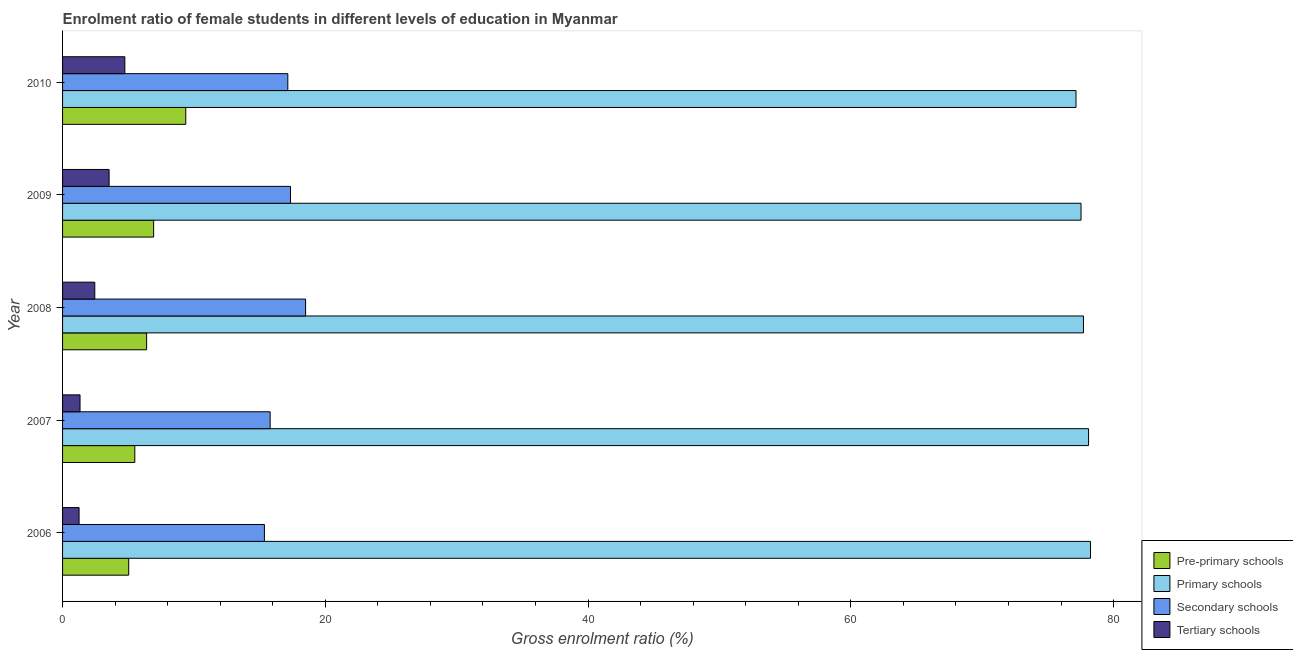How many groups of bars are there?
Your response must be concise. 5. How many bars are there on the 1st tick from the bottom?
Offer a terse response. 4. What is the label of the 5th group of bars from the top?
Make the answer very short. 2006. What is the gross enrolment ratio(male) in tertiary schools in 2006?
Offer a terse response. 1.26. Across all years, what is the maximum gross enrolment ratio(male) in primary schools?
Make the answer very short. 78.24. Across all years, what is the minimum gross enrolment ratio(male) in secondary schools?
Provide a short and direct response. 15.36. In which year was the gross enrolment ratio(male) in tertiary schools maximum?
Provide a short and direct response. 2010. What is the total gross enrolment ratio(male) in secondary schools in the graph?
Keep it short and to the point. 84.15. What is the difference between the gross enrolment ratio(male) in pre-primary schools in 2006 and that in 2007?
Offer a very short reply. -0.47. What is the difference between the gross enrolment ratio(male) in tertiary schools in 2010 and the gross enrolment ratio(male) in pre-primary schools in 2007?
Make the answer very short. -0.76. What is the average gross enrolment ratio(male) in tertiary schools per year?
Give a very brief answer. 2.66. In the year 2006, what is the difference between the gross enrolment ratio(male) in pre-primary schools and gross enrolment ratio(male) in tertiary schools?
Give a very brief answer. 3.78. Is the gross enrolment ratio(male) in secondary schools in 2006 less than that in 2007?
Your response must be concise. Yes. What is the difference between the highest and the second highest gross enrolment ratio(male) in tertiary schools?
Ensure brevity in your answer.  1.2. What is the difference between the highest and the lowest gross enrolment ratio(male) in secondary schools?
Offer a very short reply. 3.13. What does the 3rd bar from the top in 2009 represents?
Offer a very short reply. Primary schools. What does the 2nd bar from the bottom in 2007 represents?
Your answer should be compact. Primary schools. How many years are there in the graph?
Your answer should be compact. 5. What is the difference between two consecutive major ticks on the X-axis?
Keep it short and to the point. 20. Are the values on the major ticks of X-axis written in scientific E-notation?
Your answer should be very brief. No. Does the graph contain any zero values?
Your answer should be compact. No. How many legend labels are there?
Your answer should be very brief. 4. How are the legend labels stacked?
Provide a short and direct response. Vertical. What is the title of the graph?
Give a very brief answer. Enrolment ratio of female students in different levels of education in Myanmar. What is the label or title of the X-axis?
Provide a succinct answer. Gross enrolment ratio (%). What is the label or title of the Y-axis?
Give a very brief answer. Year. What is the Gross enrolment ratio (%) of Pre-primary schools in 2006?
Your response must be concise. 5.03. What is the Gross enrolment ratio (%) in Primary schools in 2006?
Ensure brevity in your answer.  78.24. What is the Gross enrolment ratio (%) in Secondary schools in 2006?
Offer a terse response. 15.36. What is the Gross enrolment ratio (%) of Tertiary schools in 2006?
Give a very brief answer. 1.26. What is the Gross enrolment ratio (%) in Pre-primary schools in 2007?
Offer a very short reply. 5.5. What is the Gross enrolment ratio (%) in Primary schools in 2007?
Offer a very short reply. 78.1. What is the Gross enrolment ratio (%) of Secondary schools in 2007?
Offer a terse response. 15.8. What is the Gross enrolment ratio (%) of Tertiary schools in 2007?
Offer a very short reply. 1.33. What is the Gross enrolment ratio (%) of Pre-primary schools in 2008?
Ensure brevity in your answer.  6.4. What is the Gross enrolment ratio (%) of Primary schools in 2008?
Provide a succinct answer. 77.71. What is the Gross enrolment ratio (%) of Secondary schools in 2008?
Offer a terse response. 18.5. What is the Gross enrolment ratio (%) of Tertiary schools in 2008?
Provide a succinct answer. 2.45. What is the Gross enrolment ratio (%) of Pre-primary schools in 2009?
Offer a very short reply. 6.93. What is the Gross enrolment ratio (%) of Primary schools in 2009?
Make the answer very short. 77.52. What is the Gross enrolment ratio (%) in Secondary schools in 2009?
Offer a terse response. 17.35. What is the Gross enrolment ratio (%) in Tertiary schools in 2009?
Make the answer very short. 3.54. What is the Gross enrolment ratio (%) of Pre-primary schools in 2010?
Offer a terse response. 9.38. What is the Gross enrolment ratio (%) of Primary schools in 2010?
Offer a terse response. 77.14. What is the Gross enrolment ratio (%) in Secondary schools in 2010?
Provide a short and direct response. 17.14. What is the Gross enrolment ratio (%) in Tertiary schools in 2010?
Offer a terse response. 4.74. Across all years, what is the maximum Gross enrolment ratio (%) of Pre-primary schools?
Offer a very short reply. 9.38. Across all years, what is the maximum Gross enrolment ratio (%) of Primary schools?
Offer a terse response. 78.24. Across all years, what is the maximum Gross enrolment ratio (%) in Secondary schools?
Provide a short and direct response. 18.5. Across all years, what is the maximum Gross enrolment ratio (%) of Tertiary schools?
Offer a very short reply. 4.74. Across all years, what is the minimum Gross enrolment ratio (%) in Pre-primary schools?
Ensure brevity in your answer.  5.03. Across all years, what is the minimum Gross enrolment ratio (%) of Primary schools?
Your answer should be very brief. 77.14. Across all years, what is the minimum Gross enrolment ratio (%) in Secondary schools?
Your response must be concise. 15.36. Across all years, what is the minimum Gross enrolment ratio (%) in Tertiary schools?
Provide a succinct answer. 1.26. What is the total Gross enrolment ratio (%) of Pre-primary schools in the graph?
Ensure brevity in your answer.  33.24. What is the total Gross enrolment ratio (%) in Primary schools in the graph?
Your response must be concise. 388.71. What is the total Gross enrolment ratio (%) of Secondary schools in the graph?
Provide a short and direct response. 84.15. What is the total Gross enrolment ratio (%) of Tertiary schools in the graph?
Make the answer very short. 13.32. What is the difference between the Gross enrolment ratio (%) of Pre-primary schools in 2006 and that in 2007?
Your response must be concise. -0.47. What is the difference between the Gross enrolment ratio (%) of Primary schools in 2006 and that in 2007?
Make the answer very short. 0.15. What is the difference between the Gross enrolment ratio (%) of Secondary schools in 2006 and that in 2007?
Provide a succinct answer. -0.44. What is the difference between the Gross enrolment ratio (%) in Tertiary schools in 2006 and that in 2007?
Make the answer very short. -0.07. What is the difference between the Gross enrolment ratio (%) in Pre-primary schools in 2006 and that in 2008?
Provide a short and direct response. -1.36. What is the difference between the Gross enrolment ratio (%) in Primary schools in 2006 and that in 2008?
Ensure brevity in your answer.  0.54. What is the difference between the Gross enrolment ratio (%) in Secondary schools in 2006 and that in 2008?
Provide a succinct answer. -3.13. What is the difference between the Gross enrolment ratio (%) of Tertiary schools in 2006 and that in 2008?
Give a very brief answer. -1.19. What is the difference between the Gross enrolment ratio (%) in Pre-primary schools in 2006 and that in 2009?
Provide a succinct answer. -1.9. What is the difference between the Gross enrolment ratio (%) of Primary schools in 2006 and that in 2009?
Make the answer very short. 0.72. What is the difference between the Gross enrolment ratio (%) of Secondary schools in 2006 and that in 2009?
Your response must be concise. -1.99. What is the difference between the Gross enrolment ratio (%) of Tertiary schools in 2006 and that in 2009?
Offer a very short reply. -2.29. What is the difference between the Gross enrolment ratio (%) of Pre-primary schools in 2006 and that in 2010?
Offer a terse response. -4.34. What is the difference between the Gross enrolment ratio (%) in Primary schools in 2006 and that in 2010?
Offer a terse response. 1.1. What is the difference between the Gross enrolment ratio (%) of Secondary schools in 2006 and that in 2010?
Ensure brevity in your answer.  -1.78. What is the difference between the Gross enrolment ratio (%) in Tertiary schools in 2006 and that in 2010?
Provide a succinct answer. -3.48. What is the difference between the Gross enrolment ratio (%) in Pre-primary schools in 2007 and that in 2008?
Your answer should be very brief. -0.9. What is the difference between the Gross enrolment ratio (%) in Primary schools in 2007 and that in 2008?
Your answer should be very brief. 0.39. What is the difference between the Gross enrolment ratio (%) of Secondary schools in 2007 and that in 2008?
Keep it short and to the point. -2.7. What is the difference between the Gross enrolment ratio (%) of Tertiary schools in 2007 and that in 2008?
Your answer should be compact. -1.12. What is the difference between the Gross enrolment ratio (%) in Pre-primary schools in 2007 and that in 2009?
Ensure brevity in your answer.  -1.43. What is the difference between the Gross enrolment ratio (%) in Primary schools in 2007 and that in 2009?
Your answer should be compact. 0.57. What is the difference between the Gross enrolment ratio (%) of Secondary schools in 2007 and that in 2009?
Make the answer very short. -1.55. What is the difference between the Gross enrolment ratio (%) in Tertiary schools in 2007 and that in 2009?
Your response must be concise. -2.21. What is the difference between the Gross enrolment ratio (%) in Pre-primary schools in 2007 and that in 2010?
Provide a short and direct response. -3.88. What is the difference between the Gross enrolment ratio (%) in Primary schools in 2007 and that in 2010?
Provide a succinct answer. 0.95. What is the difference between the Gross enrolment ratio (%) in Secondary schools in 2007 and that in 2010?
Offer a very short reply. -1.34. What is the difference between the Gross enrolment ratio (%) in Tertiary schools in 2007 and that in 2010?
Provide a succinct answer. -3.41. What is the difference between the Gross enrolment ratio (%) in Pre-primary schools in 2008 and that in 2009?
Give a very brief answer. -0.53. What is the difference between the Gross enrolment ratio (%) in Primary schools in 2008 and that in 2009?
Keep it short and to the point. 0.19. What is the difference between the Gross enrolment ratio (%) in Secondary schools in 2008 and that in 2009?
Offer a terse response. 1.15. What is the difference between the Gross enrolment ratio (%) of Tertiary schools in 2008 and that in 2009?
Your answer should be very brief. -1.09. What is the difference between the Gross enrolment ratio (%) of Pre-primary schools in 2008 and that in 2010?
Make the answer very short. -2.98. What is the difference between the Gross enrolment ratio (%) of Primary schools in 2008 and that in 2010?
Your answer should be very brief. 0.57. What is the difference between the Gross enrolment ratio (%) in Secondary schools in 2008 and that in 2010?
Offer a very short reply. 1.35. What is the difference between the Gross enrolment ratio (%) of Tertiary schools in 2008 and that in 2010?
Ensure brevity in your answer.  -2.29. What is the difference between the Gross enrolment ratio (%) in Pre-primary schools in 2009 and that in 2010?
Offer a terse response. -2.44. What is the difference between the Gross enrolment ratio (%) of Primary schools in 2009 and that in 2010?
Your answer should be compact. 0.38. What is the difference between the Gross enrolment ratio (%) in Secondary schools in 2009 and that in 2010?
Ensure brevity in your answer.  0.2. What is the difference between the Gross enrolment ratio (%) in Tertiary schools in 2009 and that in 2010?
Give a very brief answer. -1.2. What is the difference between the Gross enrolment ratio (%) of Pre-primary schools in 2006 and the Gross enrolment ratio (%) of Primary schools in 2007?
Your answer should be compact. -73.06. What is the difference between the Gross enrolment ratio (%) of Pre-primary schools in 2006 and the Gross enrolment ratio (%) of Secondary schools in 2007?
Your answer should be compact. -10.77. What is the difference between the Gross enrolment ratio (%) in Pre-primary schools in 2006 and the Gross enrolment ratio (%) in Tertiary schools in 2007?
Provide a short and direct response. 3.7. What is the difference between the Gross enrolment ratio (%) in Primary schools in 2006 and the Gross enrolment ratio (%) in Secondary schools in 2007?
Keep it short and to the point. 62.44. What is the difference between the Gross enrolment ratio (%) in Primary schools in 2006 and the Gross enrolment ratio (%) in Tertiary schools in 2007?
Your answer should be compact. 76.91. What is the difference between the Gross enrolment ratio (%) in Secondary schools in 2006 and the Gross enrolment ratio (%) in Tertiary schools in 2007?
Keep it short and to the point. 14.03. What is the difference between the Gross enrolment ratio (%) of Pre-primary schools in 2006 and the Gross enrolment ratio (%) of Primary schools in 2008?
Your response must be concise. -72.67. What is the difference between the Gross enrolment ratio (%) in Pre-primary schools in 2006 and the Gross enrolment ratio (%) in Secondary schools in 2008?
Give a very brief answer. -13.46. What is the difference between the Gross enrolment ratio (%) in Pre-primary schools in 2006 and the Gross enrolment ratio (%) in Tertiary schools in 2008?
Your answer should be compact. 2.58. What is the difference between the Gross enrolment ratio (%) of Primary schools in 2006 and the Gross enrolment ratio (%) of Secondary schools in 2008?
Offer a terse response. 59.75. What is the difference between the Gross enrolment ratio (%) of Primary schools in 2006 and the Gross enrolment ratio (%) of Tertiary schools in 2008?
Your answer should be compact. 75.79. What is the difference between the Gross enrolment ratio (%) in Secondary schools in 2006 and the Gross enrolment ratio (%) in Tertiary schools in 2008?
Your response must be concise. 12.91. What is the difference between the Gross enrolment ratio (%) in Pre-primary schools in 2006 and the Gross enrolment ratio (%) in Primary schools in 2009?
Ensure brevity in your answer.  -72.49. What is the difference between the Gross enrolment ratio (%) of Pre-primary schools in 2006 and the Gross enrolment ratio (%) of Secondary schools in 2009?
Provide a succinct answer. -12.32. What is the difference between the Gross enrolment ratio (%) of Pre-primary schools in 2006 and the Gross enrolment ratio (%) of Tertiary schools in 2009?
Your response must be concise. 1.49. What is the difference between the Gross enrolment ratio (%) in Primary schools in 2006 and the Gross enrolment ratio (%) in Secondary schools in 2009?
Your answer should be very brief. 60.89. What is the difference between the Gross enrolment ratio (%) of Primary schools in 2006 and the Gross enrolment ratio (%) of Tertiary schools in 2009?
Ensure brevity in your answer.  74.7. What is the difference between the Gross enrolment ratio (%) of Secondary schools in 2006 and the Gross enrolment ratio (%) of Tertiary schools in 2009?
Offer a very short reply. 11.82. What is the difference between the Gross enrolment ratio (%) of Pre-primary schools in 2006 and the Gross enrolment ratio (%) of Primary schools in 2010?
Give a very brief answer. -72.11. What is the difference between the Gross enrolment ratio (%) in Pre-primary schools in 2006 and the Gross enrolment ratio (%) in Secondary schools in 2010?
Give a very brief answer. -12.11. What is the difference between the Gross enrolment ratio (%) in Pre-primary schools in 2006 and the Gross enrolment ratio (%) in Tertiary schools in 2010?
Provide a short and direct response. 0.29. What is the difference between the Gross enrolment ratio (%) in Primary schools in 2006 and the Gross enrolment ratio (%) in Secondary schools in 2010?
Your response must be concise. 61.1. What is the difference between the Gross enrolment ratio (%) of Primary schools in 2006 and the Gross enrolment ratio (%) of Tertiary schools in 2010?
Provide a succinct answer. 73.5. What is the difference between the Gross enrolment ratio (%) in Secondary schools in 2006 and the Gross enrolment ratio (%) in Tertiary schools in 2010?
Your answer should be compact. 10.62. What is the difference between the Gross enrolment ratio (%) in Pre-primary schools in 2007 and the Gross enrolment ratio (%) in Primary schools in 2008?
Your answer should be very brief. -72.21. What is the difference between the Gross enrolment ratio (%) of Pre-primary schools in 2007 and the Gross enrolment ratio (%) of Secondary schools in 2008?
Your response must be concise. -13. What is the difference between the Gross enrolment ratio (%) in Pre-primary schools in 2007 and the Gross enrolment ratio (%) in Tertiary schools in 2008?
Your answer should be compact. 3.05. What is the difference between the Gross enrolment ratio (%) in Primary schools in 2007 and the Gross enrolment ratio (%) in Secondary schools in 2008?
Provide a short and direct response. 59.6. What is the difference between the Gross enrolment ratio (%) in Primary schools in 2007 and the Gross enrolment ratio (%) in Tertiary schools in 2008?
Your response must be concise. 75.64. What is the difference between the Gross enrolment ratio (%) in Secondary schools in 2007 and the Gross enrolment ratio (%) in Tertiary schools in 2008?
Provide a short and direct response. 13.35. What is the difference between the Gross enrolment ratio (%) of Pre-primary schools in 2007 and the Gross enrolment ratio (%) of Primary schools in 2009?
Offer a very short reply. -72.02. What is the difference between the Gross enrolment ratio (%) of Pre-primary schools in 2007 and the Gross enrolment ratio (%) of Secondary schools in 2009?
Keep it short and to the point. -11.85. What is the difference between the Gross enrolment ratio (%) in Pre-primary schools in 2007 and the Gross enrolment ratio (%) in Tertiary schools in 2009?
Give a very brief answer. 1.96. What is the difference between the Gross enrolment ratio (%) of Primary schools in 2007 and the Gross enrolment ratio (%) of Secondary schools in 2009?
Make the answer very short. 60.75. What is the difference between the Gross enrolment ratio (%) in Primary schools in 2007 and the Gross enrolment ratio (%) in Tertiary schools in 2009?
Provide a succinct answer. 74.55. What is the difference between the Gross enrolment ratio (%) of Secondary schools in 2007 and the Gross enrolment ratio (%) of Tertiary schools in 2009?
Your response must be concise. 12.26. What is the difference between the Gross enrolment ratio (%) in Pre-primary schools in 2007 and the Gross enrolment ratio (%) in Primary schools in 2010?
Give a very brief answer. -71.64. What is the difference between the Gross enrolment ratio (%) in Pre-primary schools in 2007 and the Gross enrolment ratio (%) in Secondary schools in 2010?
Offer a terse response. -11.65. What is the difference between the Gross enrolment ratio (%) of Pre-primary schools in 2007 and the Gross enrolment ratio (%) of Tertiary schools in 2010?
Your response must be concise. 0.76. What is the difference between the Gross enrolment ratio (%) of Primary schools in 2007 and the Gross enrolment ratio (%) of Secondary schools in 2010?
Offer a very short reply. 60.95. What is the difference between the Gross enrolment ratio (%) in Primary schools in 2007 and the Gross enrolment ratio (%) in Tertiary schools in 2010?
Offer a very short reply. 73.36. What is the difference between the Gross enrolment ratio (%) in Secondary schools in 2007 and the Gross enrolment ratio (%) in Tertiary schools in 2010?
Offer a terse response. 11.06. What is the difference between the Gross enrolment ratio (%) in Pre-primary schools in 2008 and the Gross enrolment ratio (%) in Primary schools in 2009?
Your answer should be compact. -71.12. What is the difference between the Gross enrolment ratio (%) of Pre-primary schools in 2008 and the Gross enrolment ratio (%) of Secondary schools in 2009?
Make the answer very short. -10.95. What is the difference between the Gross enrolment ratio (%) in Pre-primary schools in 2008 and the Gross enrolment ratio (%) in Tertiary schools in 2009?
Make the answer very short. 2.86. What is the difference between the Gross enrolment ratio (%) in Primary schools in 2008 and the Gross enrolment ratio (%) in Secondary schools in 2009?
Make the answer very short. 60.36. What is the difference between the Gross enrolment ratio (%) in Primary schools in 2008 and the Gross enrolment ratio (%) in Tertiary schools in 2009?
Provide a short and direct response. 74.17. What is the difference between the Gross enrolment ratio (%) of Secondary schools in 2008 and the Gross enrolment ratio (%) of Tertiary schools in 2009?
Offer a very short reply. 14.95. What is the difference between the Gross enrolment ratio (%) in Pre-primary schools in 2008 and the Gross enrolment ratio (%) in Primary schools in 2010?
Your answer should be very brief. -70.74. What is the difference between the Gross enrolment ratio (%) of Pre-primary schools in 2008 and the Gross enrolment ratio (%) of Secondary schools in 2010?
Keep it short and to the point. -10.75. What is the difference between the Gross enrolment ratio (%) in Pre-primary schools in 2008 and the Gross enrolment ratio (%) in Tertiary schools in 2010?
Make the answer very short. 1.66. What is the difference between the Gross enrolment ratio (%) in Primary schools in 2008 and the Gross enrolment ratio (%) in Secondary schools in 2010?
Provide a succinct answer. 60.56. What is the difference between the Gross enrolment ratio (%) of Primary schools in 2008 and the Gross enrolment ratio (%) of Tertiary schools in 2010?
Keep it short and to the point. 72.97. What is the difference between the Gross enrolment ratio (%) in Secondary schools in 2008 and the Gross enrolment ratio (%) in Tertiary schools in 2010?
Your answer should be very brief. 13.76. What is the difference between the Gross enrolment ratio (%) in Pre-primary schools in 2009 and the Gross enrolment ratio (%) in Primary schools in 2010?
Your answer should be very brief. -70.21. What is the difference between the Gross enrolment ratio (%) in Pre-primary schools in 2009 and the Gross enrolment ratio (%) in Secondary schools in 2010?
Your answer should be compact. -10.21. What is the difference between the Gross enrolment ratio (%) in Pre-primary schools in 2009 and the Gross enrolment ratio (%) in Tertiary schools in 2010?
Your answer should be compact. 2.19. What is the difference between the Gross enrolment ratio (%) in Primary schools in 2009 and the Gross enrolment ratio (%) in Secondary schools in 2010?
Your answer should be compact. 60.38. What is the difference between the Gross enrolment ratio (%) in Primary schools in 2009 and the Gross enrolment ratio (%) in Tertiary schools in 2010?
Provide a succinct answer. 72.78. What is the difference between the Gross enrolment ratio (%) in Secondary schools in 2009 and the Gross enrolment ratio (%) in Tertiary schools in 2010?
Keep it short and to the point. 12.61. What is the average Gross enrolment ratio (%) of Pre-primary schools per year?
Offer a terse response. 6.65. What is the average Gross enrolment ratio (%) of Primary schools per year?
Your response must be concise. 77.74. What is the average Gross enrolment ratio (%) of Secondary schools per year?
Offer a very short reply. 16.83. What is the average Gross enrolment ratio (%) of Tertiary schools per year?
Your answer should be compact. 2.66. In the year 2006, what is the difference between the Gross enrolment ratio (%) of Pre-primary schools and Gross enrolment ratio (%) of Primary schools?
Offer a terse response. -73.21. In the year 2006, what is the difference between the Gross enrolment ratio (%) in Pre-primary schools and Gross enrolment ratio (%) in Secondary schools?
Your answer should be very brief. -10.33. In the year 2006, what is the difference between the Gross enrolment ratio (%) of Pre-primary schools and Gross enrolment ratio (%) of Tertiary schools?
Your response must be concise. 3.78. In the year 2006, what is the difference between the Gross enrolment ratio (%) in Primary schools and Gross enrolment ratio (%) in Secondary schools?
Keep it short and to the point. 62.88. In the year 2006, what is the difference between the Gross enrolment ratio (%) of Primary schools and Gross enrolment ratio (%) of Tertiary schools?
Provide a short and direct response. 76.99. In the year 2006, what is the difference between the Gross enrolment ratio (%) in Secondary schools and Gross enrolment ratio (%) in Tertiary schools?
Ensure brevity in your answer.  14.11. In the year 2007, what is the difference between the Gross enrolment ratio (%) in Pre-primary schools and Gross enrolment ratio (%) in Primary schools?
Keep it short and to the point. -72.6. In the year 2007, what is the difference between the Gross enrolment ratio (%) in Pre-primary schools and Gross enrolment ratio (%) in Secondary schools?
Offer a very short reply. -10.3. In the year 2007, what is the difference between the Gross enrolment ratio (%) in Pre-primary schools and Gross enrolment ratio (%) in Tertiary schools?
Give a very brief answer. 4.17. In the year 2007, what is the difference between the Gross enrolment ratio (%) in Primary schools and Gross enrolment ratio (%) in Secondary schools?
Your answer should be very brief. 62.3. In the year 2007, what is the difference between the Gross enrolment ratio (%) of Primary schools and Gross enrolment ratio (%) of Tertiary schools?
Give a very brief answer. 76.77. In the year 2007, what is the difference between the Gross enrolment ratio (%) of Secondary schools and Gross enrolment ratio (%) of Tertiary schools?
Offer a terse response. 14.47. In the year 2008, what is the difference between the Gross enrolment ratio (%) of Pre-primary schools and Gross enrolment ratio (%) of Primary schools?
Your response must be concise. -71.31. In the year 2008, what is the difference between the Gross enrolment ratio (%) in Pre-primary schools and Gross enrolment ratio (%) in Secondary schools?
Your answer should be very brief. -12.1. In the year 2008, what is the difference between the Gross enrolment ratio (%) of Pre-primary schools and Gross enrolment ratio (%) of Tertiary schools?
Make the answer very short. 3.95. In the year 2008, what is the difference between the Gross enrolment ratio (%) of Primary schools and Gross enrolment ratio (%) of Secondary schools?
Ensure brevity in your answer.  59.21. In the year 2008, what is the difference between the Gross enrolment ratio (%) in Primary schools and Gross enrolment ratio (%) in Tertiary schools?
Keep it short and to the point. 75.26. In the year 2008, what is the difference between the Gross enrolment ratio (%) in Secondary schools and Gross enrolment ratio (%) in Tertiary schools?
Offer a terse response. 16.05. In the year 2009, what is the difference between the Gross enrolment ratio (%) of Pre-primary schools and Gross enrolment ratio (%) of Primary schools?
Your response must be concise. -70.59. In the year 2009, what is the difference between the Gross enrolment ratio (%) in Pre-primary schools and Gross enrolment ratio (%) in Secondary schools?
Provide a short and direct response. -10.42. In the year 2009, what is the difference between the Gross enrolment ratio (%) in Pre-primary schools and Gross enrolment ratio (%) in Tertiary schools?
Provide a succinct answer. 3.39. In the year 2009, what is the difference between the Gross enrolment ratio (%) in Primary schools and Gross enrolment ratio (%) in Secondary schools?
Keep it short and to the point. 60.17. In the year 2009, what is the difference between the Gross enrolment ratio (%) in Primary schools and Gross enrolment ratio (%) in Tertiary schools?
Your response must be concise. 73.98. In the year 2009, what is the difference between the Gross enrolment ratio (%) of Secondary schools and Gross enrolment ratio (%) of Tertiary schools?
Your answer should be compact. 13.81. In the year 2010, what is the difference between the Gross enrolment ratio (%) of Pre-primary schools and Gross enrolment ratio (%) of Primary schools?
Give a very brief answer. -67.76. In the year 2010, what is the difference between the Gross enrolment ratio (%) of Pre-primary schools and Gross enrolment ratio (%) of Secondary schools?
Your answer should be compact. -7.77. In the year 2010, what is the difference between the Gross enrolment ratio (%) in Pre-primary schools and Gross enrolment ratio (%) in Tertiary schools?
Provide a succinct answer. 4.64. In the year 2010, what is the difference between the Gross enrolment ratio (%) in Primary schools and Gross enrolment ratio (%) in Secondary schools?
Provide a short and direct response. 60. In the year 2010, what is the difference between the Gross enrolment ratio (%) of Primary schools and Gross enrolment ratio (%) of Tertiary schools?
Provide a short and direct response. 72.4. In the year 2010, what is the difference between the Gross enrolment ratio (%) of Secondary schools and Gross enrolment ratio (%) of Tertiary schools?
Make the answer very short. 12.4. What is the ratio of the Gross enrolment ratio (%) of Pre-primary schools in 2006 to that in 2007?
Provide a short and direct response. 0.92. What is the ratio of the Gross enrolment ratio (%) of Secondary schools in 2006 to that in 2007?
Give a very brief answer. 0.97. What is the ratio of the Gross enrolment ratio (%) of Tertiary schools in 2006 to that in 2007?
Your answer should be very brief. 0.95. What is the ratio of the Gross enrolment ratio (%) in Pre-primary schools in 2006 to that in 2008?
Provide a succinct answer. 0.79. What is the ratio of the Gross enrolment ratio (%) in Secondary schools in 2006 to that in 2008?
Provide a succinct answer. 0.83. What is the ratio of the Gross enrolment ratio (%) of Tertiary schools in 2006 to that in 2008?
Ensure brevity in your answer.  0.51. What is the ratio of the Gross enrolment ratio (%) of Pre-primary schools in 2006 to that in 2009?
Provide a short and direct response. 0.73. What is the ratio of the Gross enrolment ratio (%) in Primary schools in 2006 to that in 2009?
Give a very brief answer. 1.01. What is the ratio of the Gross enrolment ratio (%) of Secondary schools in 2006 to that in 2009?
Make the answer very short. 0.89. What is the ratio of the Gross enrolment ratio (%) of Tertiary schools in 2006 to that in 2009?
Keep it short and to the point. 0.35. What is the ratio of the Gross enrolment ratio (%) in Pre-primary schools in 2006 to that in 2010?
Provide a short and direct response. 0.54. What is the ratio of the Gross enrolment ratio (%) of Primary schools in 2006 to that in 2010?
Give a very brief answer. 1.01. What is the ratio of the Gross enrolment ratio (%) of Secondary schools in 2006 to that in 2010?
Keep it short and to the point. 0.9. What is the ratio of the Gross enrolment ratio (%) in Tertiary schools in 2006 to that in 2010?
Provide a short and direct response. 0.27. What is the ratio of the Gross enrolment ratio (%) of Pre-primary schools in 2007 to that in 2008?
Ensure brevity in your answer.  0.86. What is the ratio of the Gross enrolment ratio (%) in Primary schools in 2007 to that in 2008?
Offer a very short reply. 1. What is the ratio of the Gross enrolment ratio (%) of Secondary schools in 2007 to that in 2008?
Give a very brief answer. 0.85. What is the ratio of the Gross enrolment ratio (%) of Tertiary schools in 2007 to that in 2008?
Your response must be concise. 0.54. What is the ratio of the Gross enrolment ratio (%) in Pre-primary schools in 2007 to that in 2009?
Your response must be concise. 0.79. What is the ratio of the Gross enrolment ratio (%) in Primary schools in 2007 to that in 2009?
Make the answer very short. 1.01. What is the ratio of the Gross enrolment ratio (%) in Secondary schools in 2007 to that in 2009?
Your answer should be very brief. 0.91. What is the ratio of the Gross enrolment ratio (%) of Tertiary schools in 2007 to that in 2009?
Provide a succinct answer. 0.38. What is the ratio of the Gross enrolment ratio (%) in Pre-primary schools in 2007 to that in 2010?
Ensure brevity in your answer.  0.59. What is the ratio of the Gross enrolment ratio (%) of Primary schools in 2007 to that in 2010?
Offer a terse response. 1.01. What is the ratio of the Gross enrolment ratio (%) in Secondary schools in 2007 to that in 2010?
Your response must be concise. 0.92. What is the ratio of the Gross enrolment ratio (%) in Tertiary schools in 2007 to that in 2010?
Offer a terse response. 0.28. What is the ratio of the Gross enrolment ratio (%) in Pre-primary schools in 2008 to that in 2009?
Offer a terse response. 0.92. What is the ratio of the Gross enrolment ratio (%) of Primary schools in 2008 to that in 2009?
Make the answer very short. 1. What is the ratio of the Gross enrolment ratio (%) in Secondary schools in 2008 to that in 2009?
Offer a terse response. 1.07. What is the ratio of the Gross enrolment ratio (%) of Tertiary schools in 2008 to that in 2009?
Keep it short and to the point. 0.69. What is the ratio of the Gross enrolment ratio (%) in Pre-primary schools in 2008 to that in 2010?
Your answer should be compact. 0.68. What is the ratio of the Gross enrolment ratio (%) in Primary schools in 2008 to that in 2010?
Keep it short and to the point. 1.01. What is the ratio of the Gross enrolment ratio (%) in Secondary schools in 2008 to that in 2010?
Offer a terse response. 1.08. What is the ratio of the Gross enrolment ratio (%) of Tertiary schools in 2008 to that in 2010?
Your answer should be very brief. 0.52. What is the ratio of the Gross enrolment ratio (%) of Pre-primary schools in 2009 to that in 2010?
Keep it short and to the point. 0.74. What is the ratio of the Gross enrolment ratio (%) in Primary schools in 2009 to that in 2010?
Provide a short and direct response. 1. What is the ratio of the Gross enrolment ratio (%) of Secondary schools in 2009 to that in 2010?
Provide a short and direct response. 1.01. What is the ratio of the Gross enrolment ratio (%) of Tertiary schools in 2009 to that in 2010?
Keep it short and to the point. 0.75. What is the difference between the highest and the second highest Gross enrolment ratio (%) in Pre-primary schools?
Keep it short and to the point. 2.44. What is the difference between the highest and the second highest Gross enrolment ratio (%) in Primary schools?
Keep it short and to the point. 0.15. What is the difference between the highest and the second highest Gross enrolment ratio (%) of Secondary schools?
Provide a succinct answer. 1.15. What is the difference between the highest and the second highest Gross enrolment ratio (%) in Tertiary schools?
Offer a very short reply. 1.2. What is the difference between the highest and the lowest Gross enrolment ratio (%) of Pre-primary schools?
Offer a terse response. 4.34. What is the difference between the highest and the lowest Gross enrolment ratio (%) of Primary schools?
Your answer should be compact. 1.1. What is the difference between the highest and the lowest Gross enrolment ratio (%) of Secondary schools?
Offer a very short reply. 3.13. What is the difference between the highest and the lowest Gross enrolment ratio (%) in Tertiary schools?
Offer a very short reply. 3.48. 